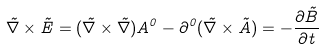<formula> <loc_0><loc_0><loc_500><loc_500>\vec { \nabla } \times \vec { E } = ( \vec { \nabla } \times \vec { \nabla } ) A ^ { 0 } - \partial ^ { 0 } ( \vec { \nabla } \times \vec { A } ) = - \frac { \partial \vec { B } } { \partial t }</formula> 